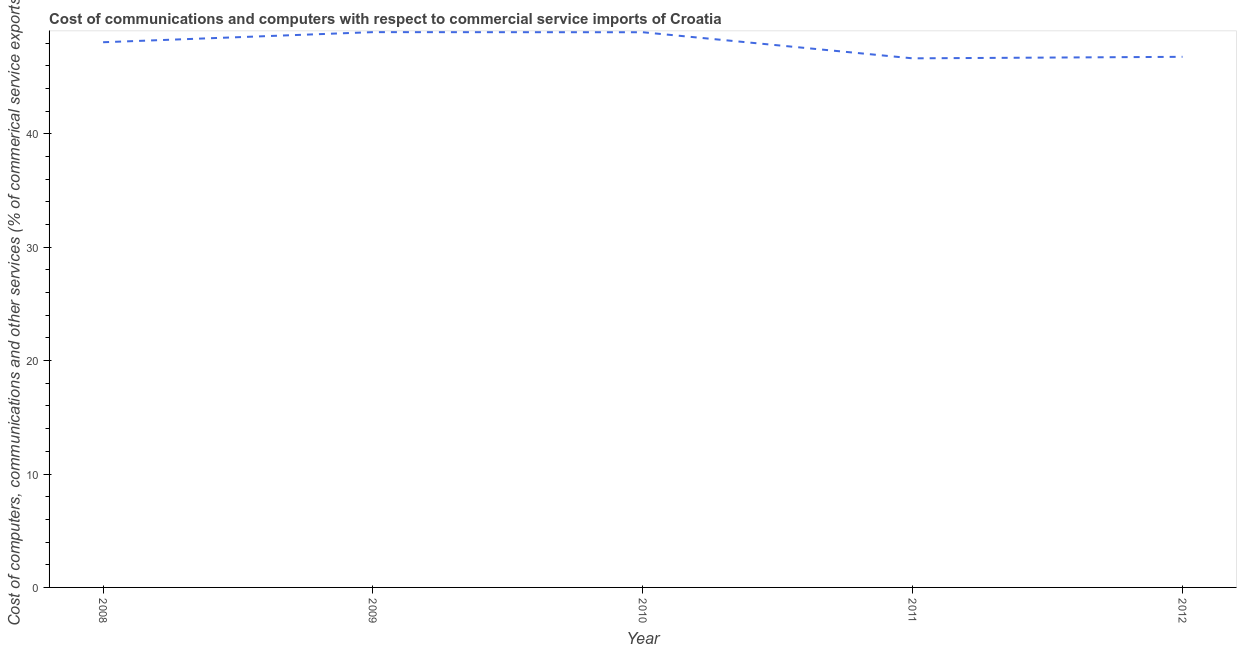What is the cost of communications in 2009?
Ensure brevity in your answer.  48.97. Across all years, what is the maximum  computer and other services?
Provide a short and direct response. 48.97. Across all years, what is the minimum cost of communications?
Make the answer very short. 46.66. What is the sum of the cost of communications?
Provide a succinct answer. 239.47. What is the difference between the  computer and other services in 2009 and 2010?
Give a very brief answer. 0.01. What is the average  computer and other services per year?
Ensure brevity in your answer.  47.89. What is the median  computer and other services?
Offer a very short reply. 48.08. In how many years, is the cost of communications greater than 20 %?
Provide a short and direct response. 5. What is the ratio of the cost of communications in 2011 to that in 2012?
Provide a short and direct response. 1. What is the difference between the highest and the second highest  computer and other services?
Keep it short and to the point. 0.01. What is the difference between the highest and the lowest cost of communications?
Ensure brevity in your answer.  2.31. In how many years, is the  computer and other services greater than the average  computer and other services taken over all years?
Keep it short and to the point. 3. Does the cost of communications monotonically increase over the years?
Offer a terse response. No. Does the graph contain any zero values?
Provide a succinct answer. No. What is the title of the graph?
Your response must be concise. Cost of communications and computers with respect to commercial service imports of Croatia. What is the label or title of the Y-axis?
Give a very brief answer. Cost of computers, communications and other services (% of commerical service exports). What is the Cost of computers, communications and other services (% of commerical service exports) in 2008?
Ensure brevity in your answer.  48.08. What is the Cost of computers, communications and other services (% of commerical service exports) in 2009?
Make the answer very short. 48.97. What is the Cost of computers, communications and other services (% of commerical service exports) in 2010?
Give a very brief answer. 48.96. What is the Cost of computers, communications and other services (% of commerical service exports) of 2011?
Provide a short and direct response. 46.66. What is the Cost of computers, communications and other services (% of commerical service exports) of 2012?
Offer a very short reply. 46.79. What is the difference between the Cost of computers, communications and other services (% of commerical service exports) in 2008 and 2009?
Make the answer very short. -0.89. What is the difference between the Cost of computers, communications and other services (% of commerical service exports) in 2008 and 2010?
Provide a succinct answer. -0.88. What is the difference between the Cost of computers, communications and other services (% of commerical service exports) in 2008 and 2011?
Provide a succinct answer. 1.42. What is the difference between the Cost of computers, communications and other services (% of commerical service exports) in 2008 and 2012?
Your answer should be very brief. 1.29. What is the difference between the Cost of computers, communications and other services (% of commerical service exports) in 2009 and 2010?
Give a very brief answer. 0.01. What is the difference between the Cost of computers, communications and other services (% of commerical service exports) in 2009 and 2011?
Your answer should be compact. 2.31. What is the difference between the Cost of computers, communications and other services (% of commerical service exports) in 2009 and 2012?
Your answer should be very brief. 2.18. What is the difference between the Cost of computers, communications and other services (% of commerical service exports) in 2010 and 2011?
Offer a very short reply. 2.3. What is the difference between the Cost of computers, communications and other services (% of commerical service exports) in 2010 and 2012?
Keep it short and to the point. 2.17. What is the difference between the Cost of computers, communications and other services (% of commerical service exports) in 2011 and 2012?
Offer a very short reply. -0.13. What is the ratio of the Cost of computers, communications and other services (% of commerical service exports) in 2008 to that in 2009?
Offer a very short reply. 0.98. What is the ratio of the Cost of computers, communications and other services (% of commerical service exports) in 2008 to that in 2010?
Provide a short and direct response. 0.98. What is the ratio of the Cost of computers, communications and other services (% of commerical service exports) in 2008 to that in 2011?
Provide a succinct answer. 1.03. What is the ratio of the Cost of computers, communications and other services (% of commerical service exports) in 2009 to that in 2010?
Your answer should be very brief. 1. What is the ratio of the Cost of computers, communications and other services (% of commerical service exports) in 2009 to that in 2012?
Offer a terse response. 1.05. What is the ratio of the Cost of computers, communications and other services (% of commerical service exports) in 2010 to that in 2011?
Ensure brevity in your answer.  1.05. What is the ratio of the Cost of computers, communications and other services (% of commerical service exports) in 2010 to that in 2012?
Your answer should be very brief. 1.05. 